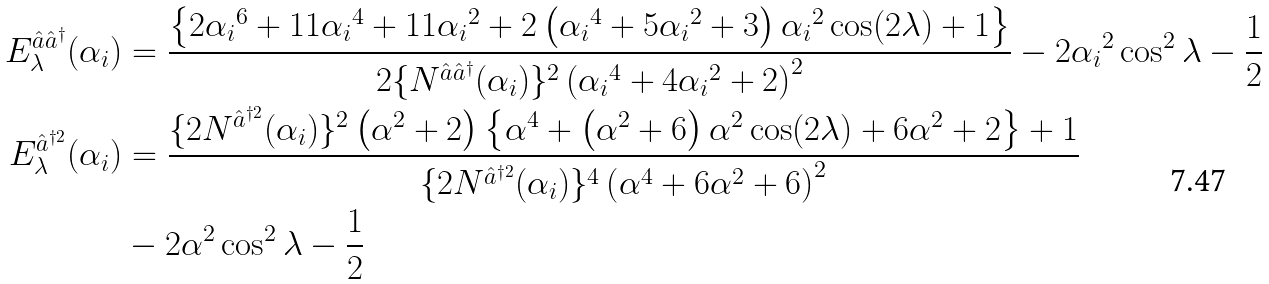Convert formula to latex. <formula><loc_0><loc_0><loc_500><loc_500>E _ { \lambda } ^ { \hat { a } \hat { a } ^ { \dag } } ( \alpha _ { i } ) & = \frac { \left \{ 2 { \alpha _ { i } } ^ { 6 } + 1 1 { \alpha _ { i } } ^ { 4 } + 1 1 { \alpha _ { i } } ^ { 2 } + 2 \left ( { \alpha _ { i } } ^ { 4 } + 5 { \alpha _ { i } } ^ { 2 } + 3 \right ) { \alpha _ { i } } ^ { 2 } \cos ( 2 \lambda ) + 1 \right \} } { 2 { \{ N ^ { \hat { a } \hat { a } ^ { \dag } } ( { \alpha _ { i } } ) \} ^ { 2 } } \left ( { \alpha _ { i } } ^ { 4 } + 4 { \alpha _ { i } } ^ { 2 } + 2 \right ) ^ { 2 } } - 2 { \alpha _ { i } } ^ { 2 } \cos ^ { 2 } \lambda - \frac { 1 } { 2 } \\ E _ { \lambda } ^ { \hat { a } ^ { \dag 2 } } ( \alpha _ { i } ) & = \frac { \{ 2 N ^ { \hat { a } ^ { \dag 2 } } ( { \alpha _ { i } } ) \} ^ { 2 } \left ( \alpha ^ { 2 } + 2 \right ) \left \{ \alpha ^ { 4 } + \left ( \alpha ^ { 2 } + 6 \right ) \alpha ^ { 2 } \cos ( 2 \lambda ) + 6 \alpha ^ { 2 } + 2 \right \} + 1 } { { \{ 2 N ^ { \hat { a } ^ { \dag 2 } } ( { \alpha _ { i } } ) \} ^ { 4 } } \left ( \alpha ^ { 4 } + 6 \alpha ^ { 2 } + 6 \right ) ^ { 2 } } \\ & - 2 \alpha ^ { 2 } \cos ^ { 2 } \lambda - \frac { 1 } { 2 }</formula> 